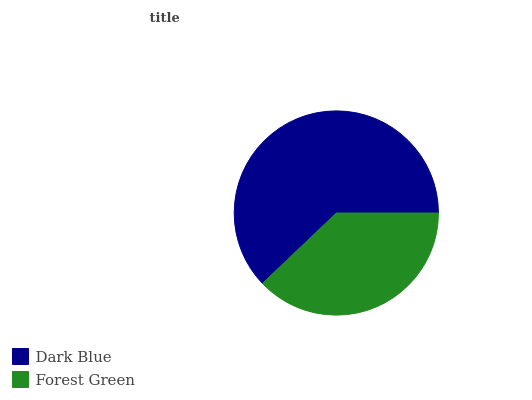Is Forest Green the minimum?
Answer yes or no. Yes. Is Dark Blue the maximum?
Answer yes or no. Yes. Is Forest Green the maximum?
Answer yes or no. No. Is Dark Blue greater than Forest Green?
Answer yes or no. Yes. Is Forest Green less than Dark Blue?
Answer yes or no. Yes. Is Forest Green greater than Dark Blue?
Answer yes or no. No. Is Dark Blue less than Forest Green?
Answer yes or no. No. Is Dark Blue the high median?
Answer yes or no. Yes. Is Forest Green the low median?
Answer yes or no. Yes. Is Forest Green the high median?
Answer yes or no. No. Is Dark Blue the low median?
Answer yes or no. No. 